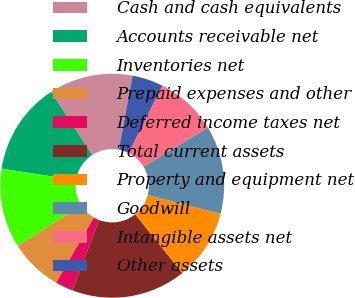Convert chart. <chart><loc_0><loc_0><loc_500><loc_500><pie_chart><fcel>Cash and cash equivalents<fcel>Accounts receivable net<fcel>Inventories net<fcel>Prepaid expenses and other<fcel>Deferred income taxes net<fcel>Total current assets<fcel>Property and equipment net<fcel>Goodwill<fcel>Intangible assets net<fcel>Other assets<nl><fcel>12.1%<fcel>13.38%<fcel>11.46%<fcel>7.64%<fcel>2.55%<fcel>16.56%<fcel>10.19%<fcel>12.74%<fcel>8.92%<fcel>4.46%<nl></chart> 